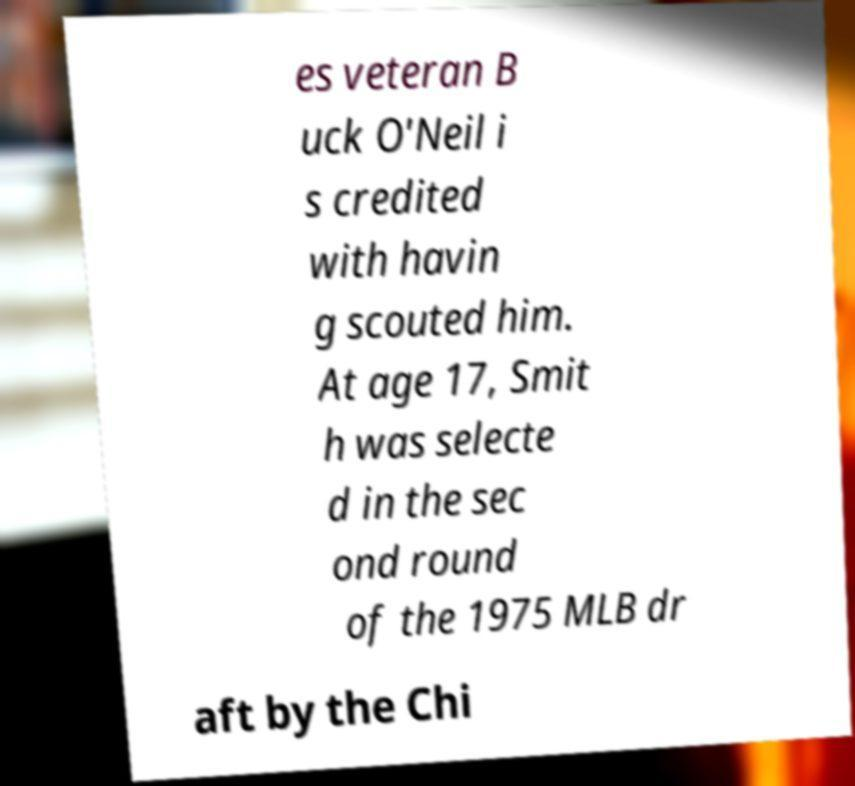For documentation purposes, I need the text within this image transcribed. Could you provide that? es veteran B uck O'Neil i s credited with havin g scouted him. At age 17, Smit h was selecte d in the sec ond round of the 1975 MLB dr aft by the Chi 